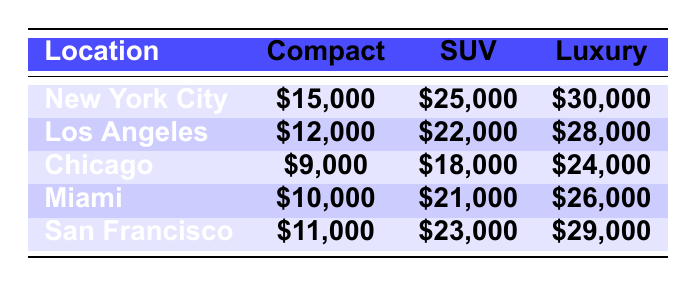What's the total revenue from Luxury vehicles in New York City? The revenue from Luxury vehicles in New York City is listed in the table as \$30,000.
Answer: \$30,000 What is the difference in revenue between SUVs and Compact cars in Los Angeles? The revenue from SUVs in Los Angeles is \$22,000 and from Compact cars is \$12,000. The difference is \$22,000 - \$12,000 = \$10,000.
Answer: \$10,000 Which location has the highest revenue from Compact vehicles? The table shows the revenue from Compact vehicles for each location; New York City has the highest at \$15,000.
Answer: New York City What is the average revenue for Luxury vehicles across all locations? The total revenue for Luxury vehicles is \$30,000 (NYC) + \$28,000 (LA) + \$24,000 (Chicago) + \$26,000 (Miami) + \$29,000 (San Francisco) = \$137,000. There are 5 locations, so the average is \$137,000 / 5 = \$27,400.
Answer: \$27,400 Is the revenue from SUVs in Miami greater than that in Chicago? Miami's SUV revenue is \$21,000 while Chicago's is \$18,000. Since \$21,000 > \$18,000, the statement is true.
Answer: Yes What is the total revenue from Compact vehicles across all locations? The total revenue is calculated as follows: \$15,000 (NYC) + \$12,000 (LA) + \$9,000 (Chicago) + \$10,000 (Miami) + \$11,000 (San Francisco) = \$57,000.
Answer: \$57,000 Which location has the lowest total revenue from all types of vehicles combined? Calculating the total for each location: NYC = \$15,000 + \$25,000 + \$30,000 = \$70,000; LA = \$12,000 + \$22,000 + \$28,000 = \$62,000; Chicago = \$9,000 + \$18,000 + \$24,000 = \$51,000; Miami = \$10,000 + \$21,000 + \$26,000 = \$57,000; San Francisco = \$11,000 + \$23,000 + \$29,000 = \$63,000. The lowest is Chicago at \$51,000.
Answer: Chicago What is the ratio of revenue from SUVs to Luxury vehicles in San Francisco? The revenue for SUVs in San Francisco is \$23,000, and for Luxury vehicles, it is \$29,000. The ratio is \$23,000 to \$29,000, which simplifies to approximately 0.79 when expressed as a fraction.
Answer: 0.79 Is the total revenue from Compact vehicles across New York City and San Francisco greater than that from Luxury vehicles across the same locations? The revenue from Compact vehicles in NYC is \$15,000 and \$11,000 in San Francisco, totaling \$26,000. The Luxury vehicle revenue in these locations is \$30,000 (NYC) + \$29,000 (SF) = \$59,000. Since \$26,000 < \$59,000, the statement is false.
Answer: No What is the total revenue from all vehicles in Los Angeles? The total for Los Angeles is calculated as follows: \$12,000 (Compact) + \$22,000 (SUV) + \$28,000 (Luxury) = \$62,000.
Answer: \$62,000 